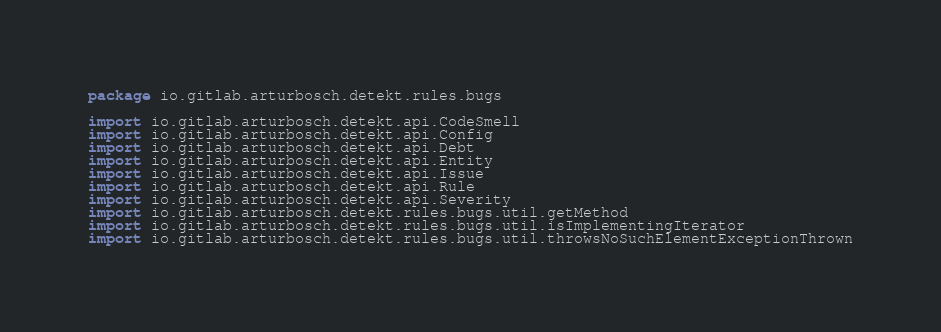Convert code to text. <code><loc_0><loc_0><loc_500><loc_500><_Kotlin_>package io.gitlab.arturbosch.detekt.rules.bugs

import io.gitlab.arturbosch.detekt.api.CodeSmell
import io.gitlab.arturbosch.detekt.api.Config
import io.gitlab.arturbosch.detekt.api.Debt
import io.gitlab.arturbosch.detekt.api.Entity
import io.gitlab.arturbosch.detekt.api.Issue
import io.gitlab.arturbosch.detekt.api.Rule
import io.gitlab.arturbosch.detekt.api.Severity
import io.gitlab.arturbosch.detekt.rules.bugs.util.getMethod
import io.gitlab.arturbosch.detekt.rules.bugs.util.isImplementingIterator
import io.gitlab.arturbosch.detekt.rules.bugs.util.throwsNoSuchElementExceptionThrown</code> 